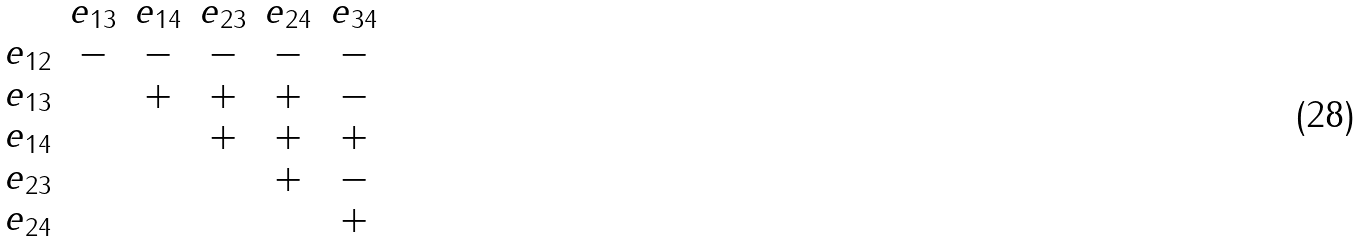Convert formula to latex. <formula><loc_0><loc_0><loc_500><loc_500>\begin{matrix} & e _ { 1 3 } & e _ { 1 4 } & e _ { 2 3 } & e _ { 2 4 } & e _ { 3 4 } \\ e _ { 1 2 } & - & - & - & - & - \\ e _ { 1 3 } & & + & + & + & - \\ e _ { 1 4 } & & & + & + & + \\ e _ { 2 3 } & & & & + & - \\ e _ { 2 4 } & & & & & + \end{matrix}</formula> 